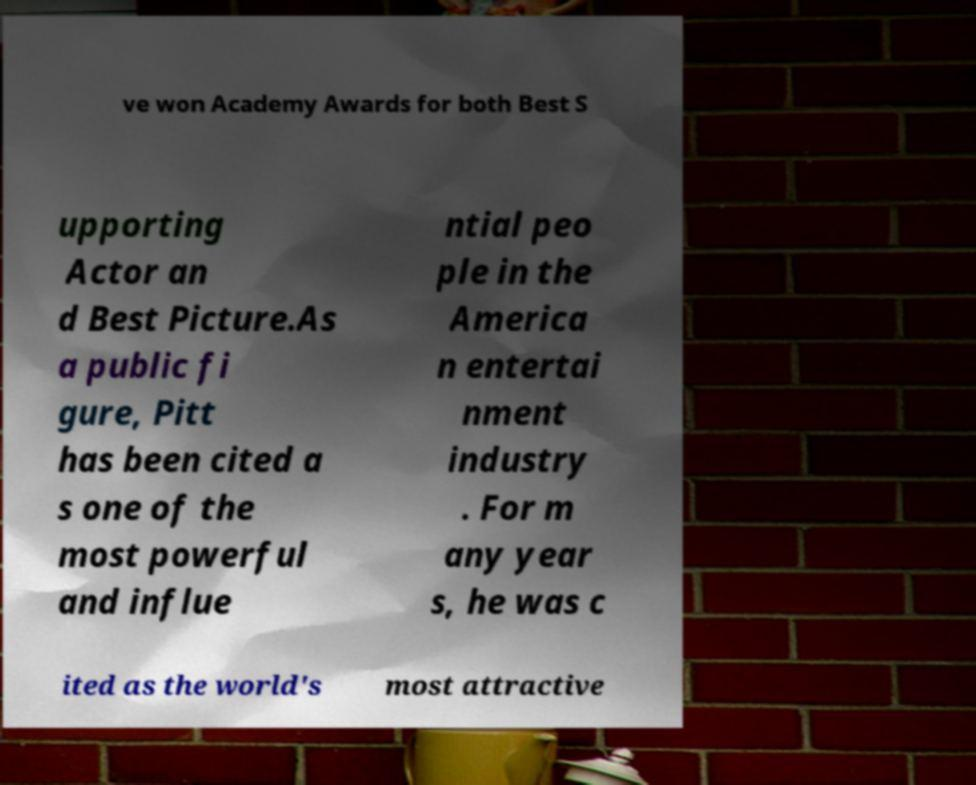For documentation purposes, I need the text within this image transcribed. Could you provide that? ve won Academy Awards for both Best S upporting Actor an d Best Picture.As a public fi gure, Pitt has been cited a s one of the most powerful and influe ntial peo ple in the America n entertai nment industry . For m any year s, he was c ited as the world's most attractive 